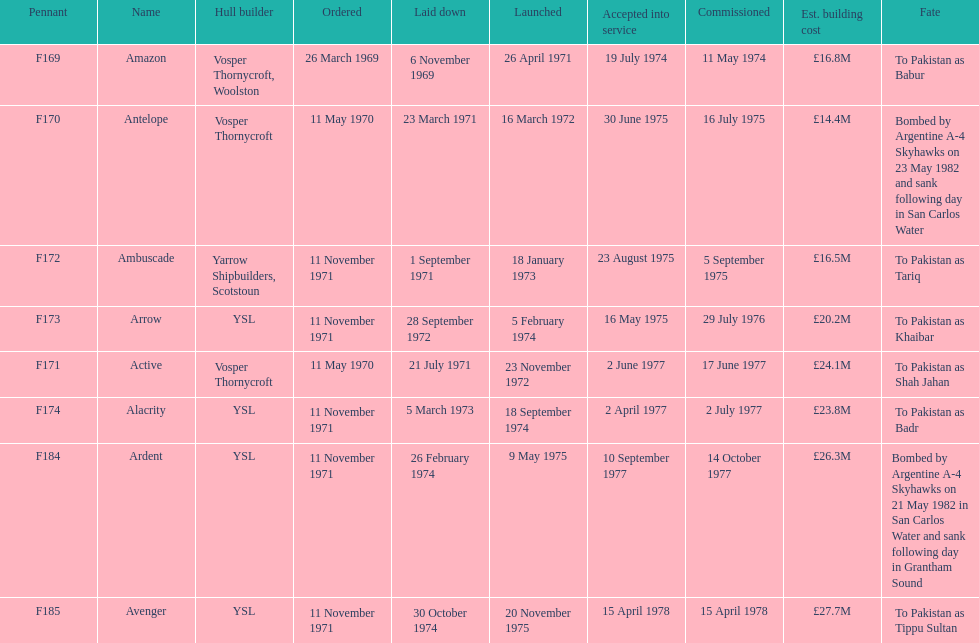During september, how many ships were set for construction? 2. 